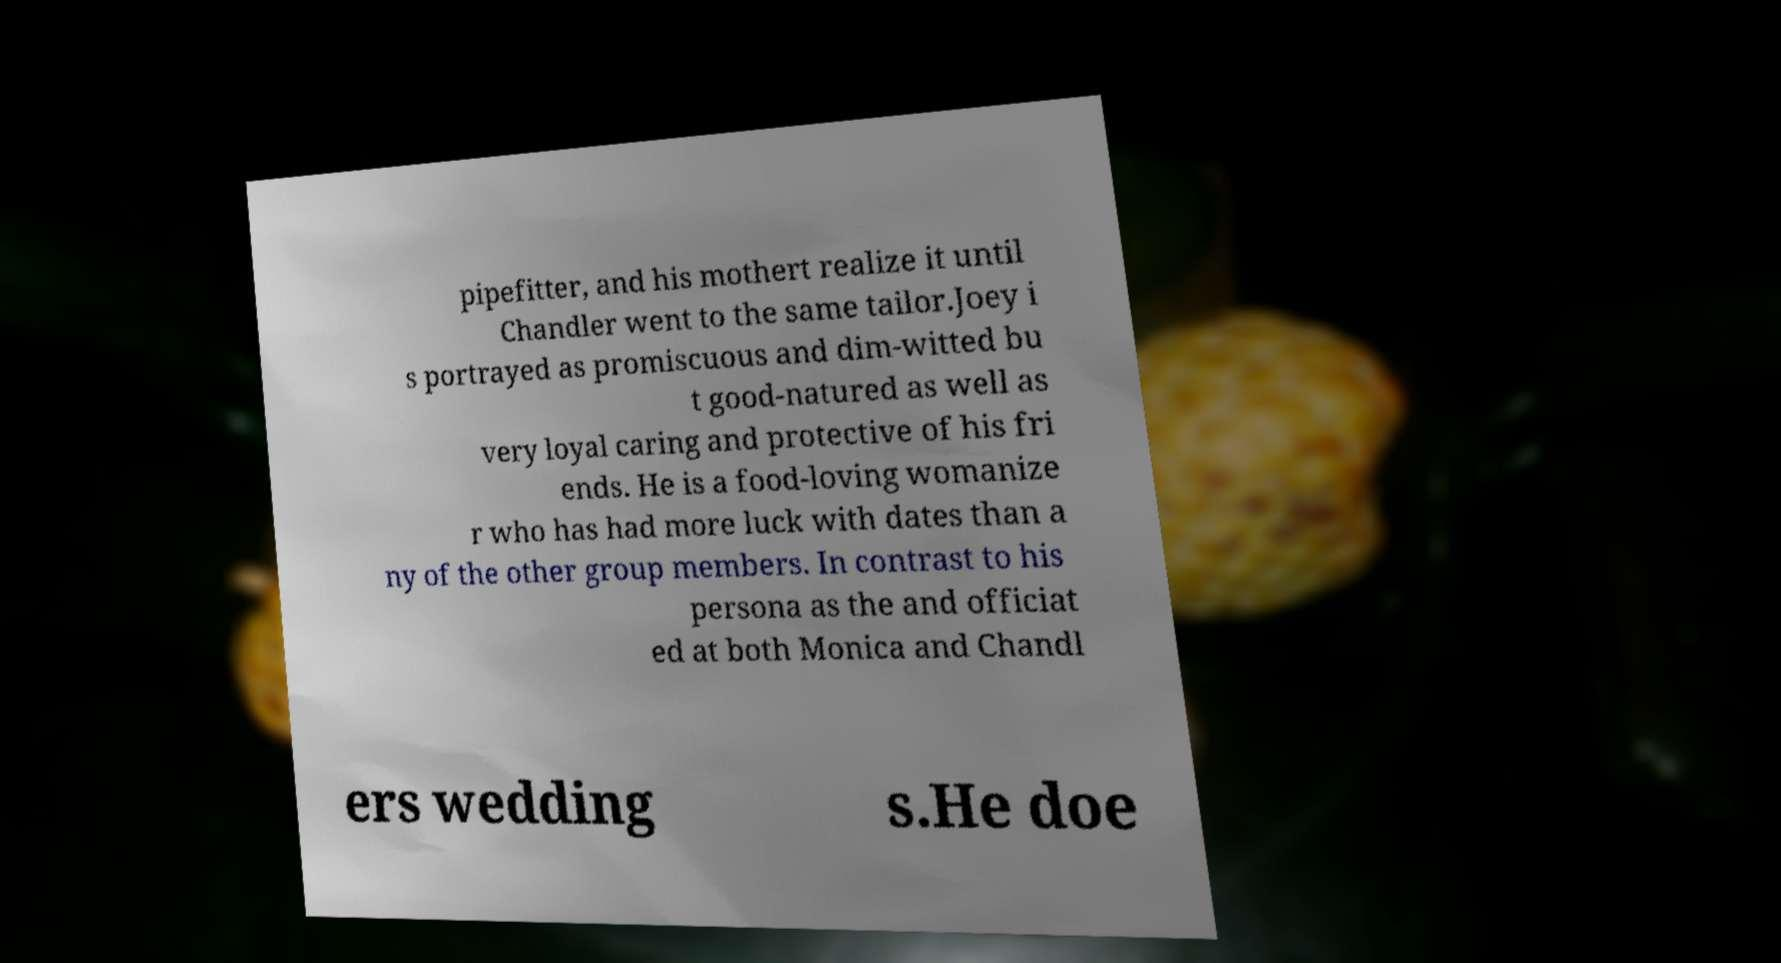There's text embedded in this image that I need extracted. Can you transcribe it verbatim? pipefitter, and his mothert realize it until Chandler went to the same tailor.Joey i s portrayed as promiscuous and dim-witted bu t good-natured as well as very loyal caring and protective of his fri ends. He is a food-loving womanize r who has had more luck with dates than a ny of the other group members. In contrast to his persona as the and officiat ed at both Monica and Chandl ers wedding s.He doe 